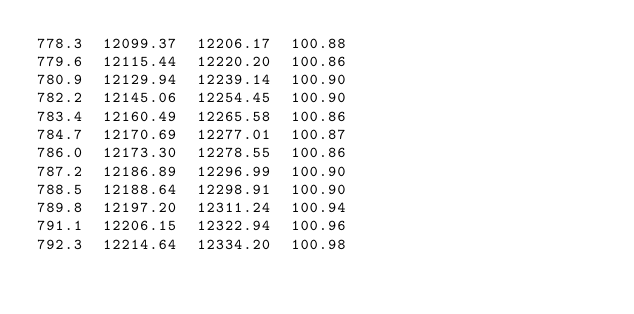Convert code to text. <code><loc_0><loc_0><loc_500><loc_500><_SML_>778.3  12099.37  12206.17  100.88
779.6  12115.44  12220.20  100.86
780.9  12129.94  12239.14  100.90
782.2  12145.06  12254.45  100.90
783.4  12160.49  12265.58  100.86
784.7  12170.69  12277.01  100.87
786.0  12173.30  12278.55  100.86
787.2  12186.89  12296.99  100.90
788.5  12188.64  12298.91  100.90
789.8  12197.20  12311.24  100.94
791.1  12206.15  12322.94  100.96
792.3  12214.64  12334.20  100.98</code> 